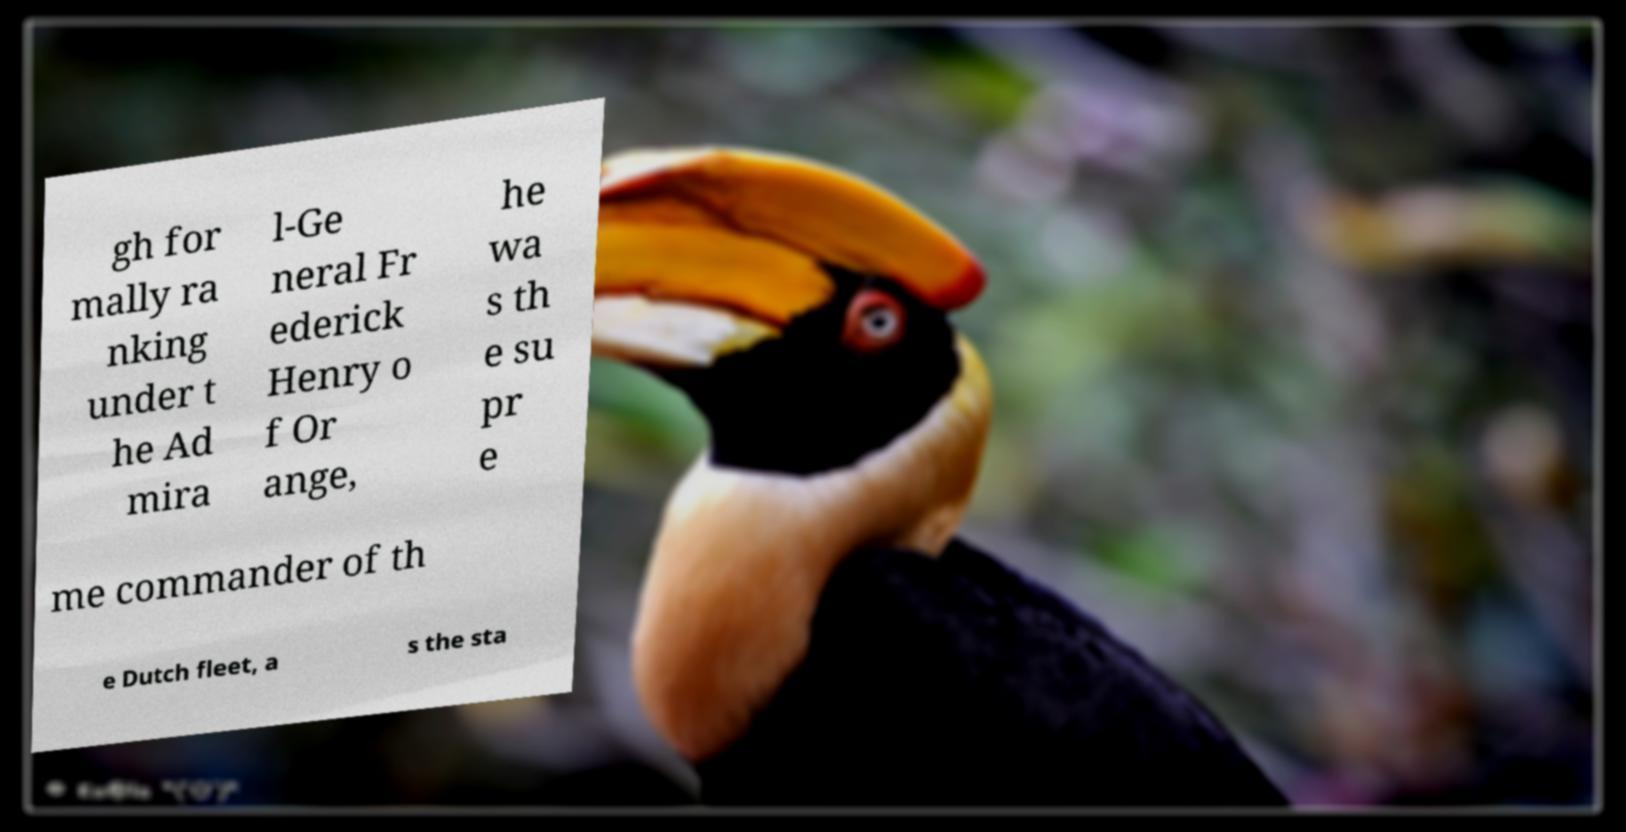Could you assist in decoding the text presented in this image and type it out clearly? gh for mally ra nking under t he Ad mira l-Ge neral Fr ederick Henry o f Or ange, he wa s th e su pr e me commander of th e Dutch fleet, a s the sta 